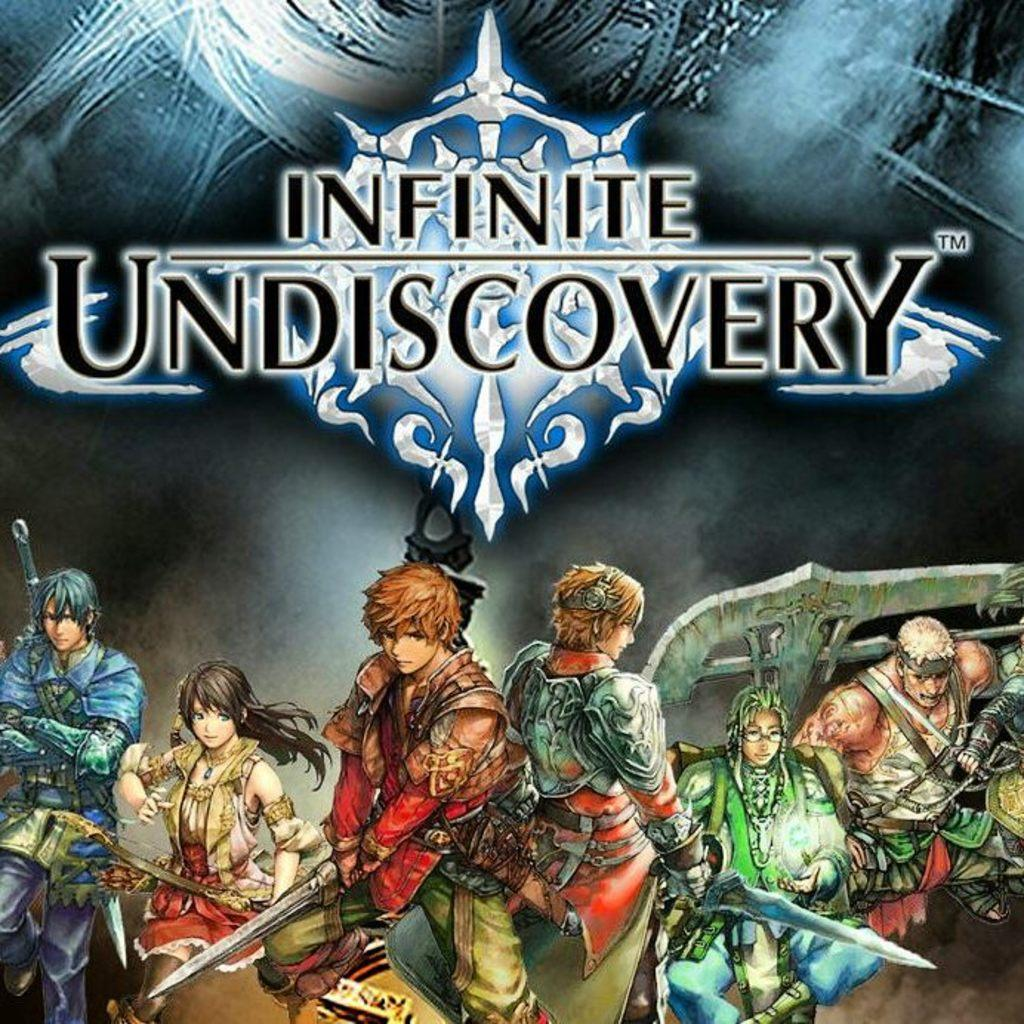Provide a one-sentence caption for the provided image. Video game cover for the game Infinite Undiscovery. 